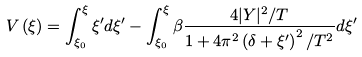Convert formula to latex. <formula><loc_0><loc_0><loc_500><loc_500>V \left ( \xi \right ) = \int _ { \xi _ { 0 } } ^ { \xi } \xi ^ { \prime } d \xi ^ { \prime } - \int _ { \xi _ { 0 } } ^ { \xi } \beta \frac { 4 | Y | ^ { 2 } / T } { 1 + 4 \pi ^ { 2 } \left ( \delta + \xi ^ { \prime } \right ) ^ { 2 } / T ^ { 2 } } d \xi ^ { \prime }</formula> 